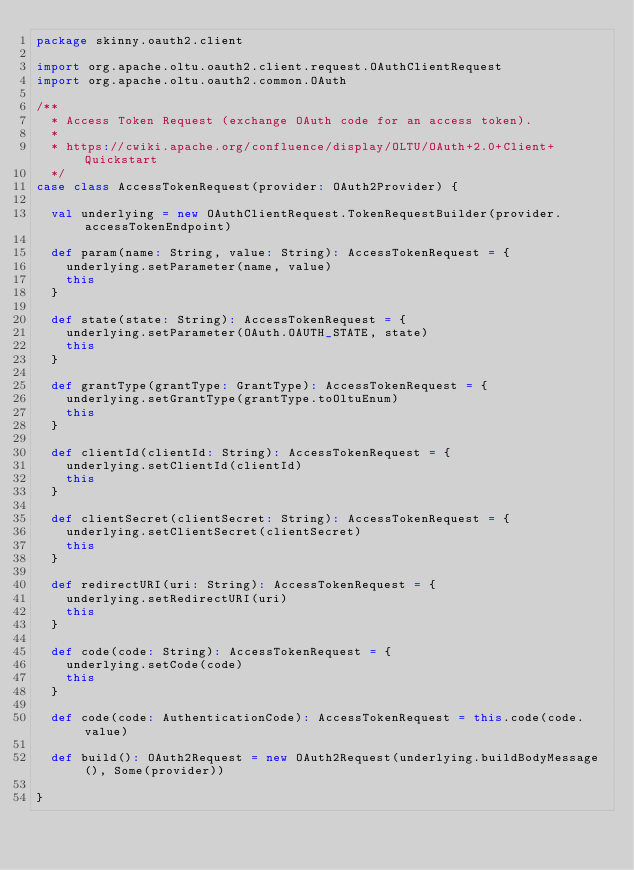Convert code to text. <code><loc_0><loc_0><loc_500><loc_500><_Scala_>package skinny.oauth2.client

import org.apache.oltu.oauth2.client.request.OAuthClientRequest
import org.apache.oltu.oauth2.common.OAuth

/**
  * Access Token Request (exchange OAuth code for an access token).
  *
  * https://cwiki.apache.org/confluence/display/OLTU/OAuth+2.0+Client+Quickstart
  */
case class AccessTokenRequest(provider: OAuth2Provider) {

  val underlying = new OAuthClientRequest.TokenRequestBuilder(provider.accessTokenEndpoint)

  def param(name: String, value: String): AccessTokenRequest = {
    underlying.setParameter(name, value)
    this
  }

  def state(state: String): AccessTokenRequest = {
    underlying.setParameter(OAuth.OAUTH_STATE, state)
    this
  }

  def grantType(grantType: GrantType): AccessTokenRequest = {
    underlying.setGrantType(grantType.toOltuEnum)
    this
  }

  def clientId(clientId: String): AccessTokenRequest = {
    underlying.setClientId(clientId)
    this
  }

  def clientSecret(clientSecret: String): AccessTokenRequest = {
    underlying.setClientSecret(clientSecret)
    this
  }

  def redirectURI(uri: String): AccessTokenRequest = {
    underlying.setRedirectURI(uri)
    this
  }

  def code(code: String): AccessTokenRequest = {
    underlying.setCode(code)
    this
  }

  def code(code: AuthenticationCode): AccessTokenRequest = this.code(code.value)

  def build(): OAuth2Request = new OAuth2Request(underlying.buildBodyMessage(), Some(provider))

}
</code> 